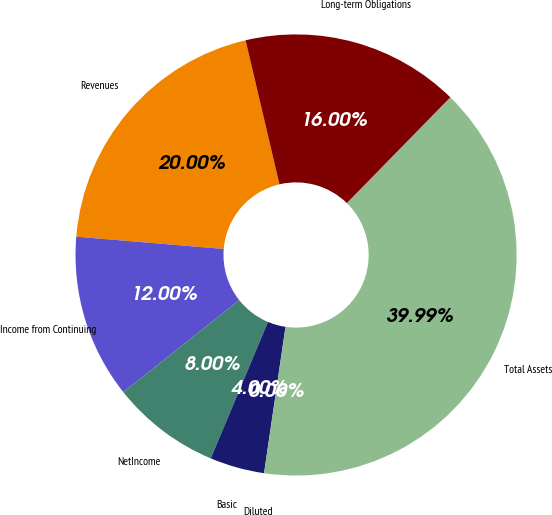Convert chart to OTSL. <chart><loc_0><loc_0><loc_500><loc_500><pie_chart><fcel>Revenues<fcel>Income from Continuing<fcel>NetIncome<fcel>Basic<fcel>Diluted<fcel>Total Assets<fcel>Long-term Obligations<nl><fcel>20.0%<fcel>12.0%<fcel>8.0%<fcel>4.0%<fcel>0.0%<fcel>39.99%<fcel>16.0%<nl></chart> 